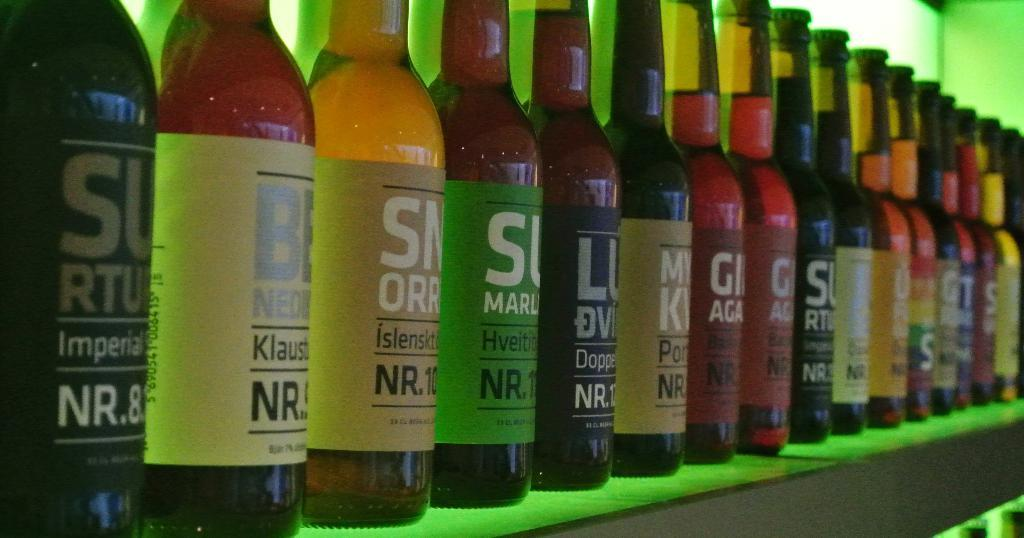<image>
Offer a succinct explanation of the picture presented. A collection of bottles on a shelf wih the first advertising NR.8. 